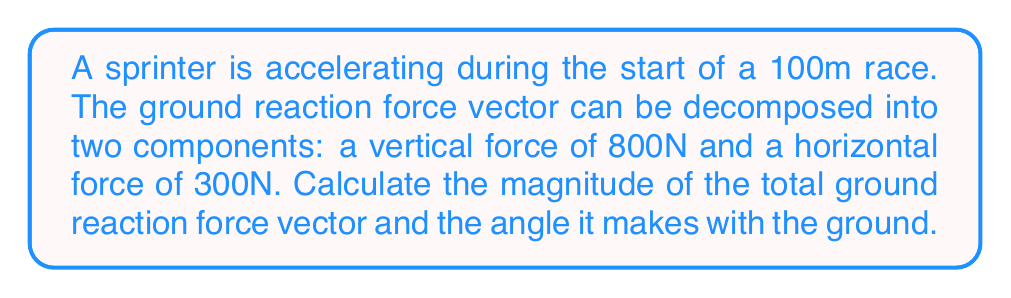What is the answer to this math problem? To solve this problem, we'll use vector analysis and trigonometry. Let's break it down step-by-step:

1. Identify the components:
   - Vertical force (F_v) = 800N
   - Horizontal force (F_h) = 300N

2. Calculate the magnitude of the total force vector:
   We can use the Pythagorean theorem to find the magnitude of the resultant force.

   $$F_{total} = \sqrt{F_v^2 + F_h^2}$$
   $$F_{total} = \sqrt{800^2 + 300^2}$$
   $$F_{total} = \sqrt{640,000 + 90,000}$$
   $$F_{total} = \sqrt{730,000}$$
   $$F_{total} \approx 854.4 \text{ N}$$

3. Calculate the angle with the ground:
   We can use the arctangent function to find the angle between the force vector and the ground.

   $$\theta = \arctan(\frac{F_v}{F_h})$$
   $$\theta = \arctan(\frac{800}{300})$$
   $$\theta = \arctan(2.667)$$
   $$\theta \approx 69.44^\circ$$

This angle is measured from the horizontal (ground) to the force vector.

[asy]
import geometry;

size(200);
draw((0,0)--(4,0), arrow=Arrow(TeXHead));
draw((0,0)--(0,4), arrow=Arrow(TeXHead));
draw((0,0)--(3,8), arrow=Arrow(TeXHead));

label("300N", (2,-0.5));
label("800N", (-0.5,2));
label("854.4N", (1.8,4.5));
label("69.44°", (0.8,0.5));

dot((0,0));
[/asy]

Understanding these force vectors is crucial for improving sprinting technique. The magnitude of the total force and its angle with the ground can provide insights into the efficiency of the sprinter's push-off and overall power generation during acceleration.
Answer: The magnitude of the total ground reaction force vector is approximately 854.4 N, and it makes an angle of approximately 69.44° with the ground. 